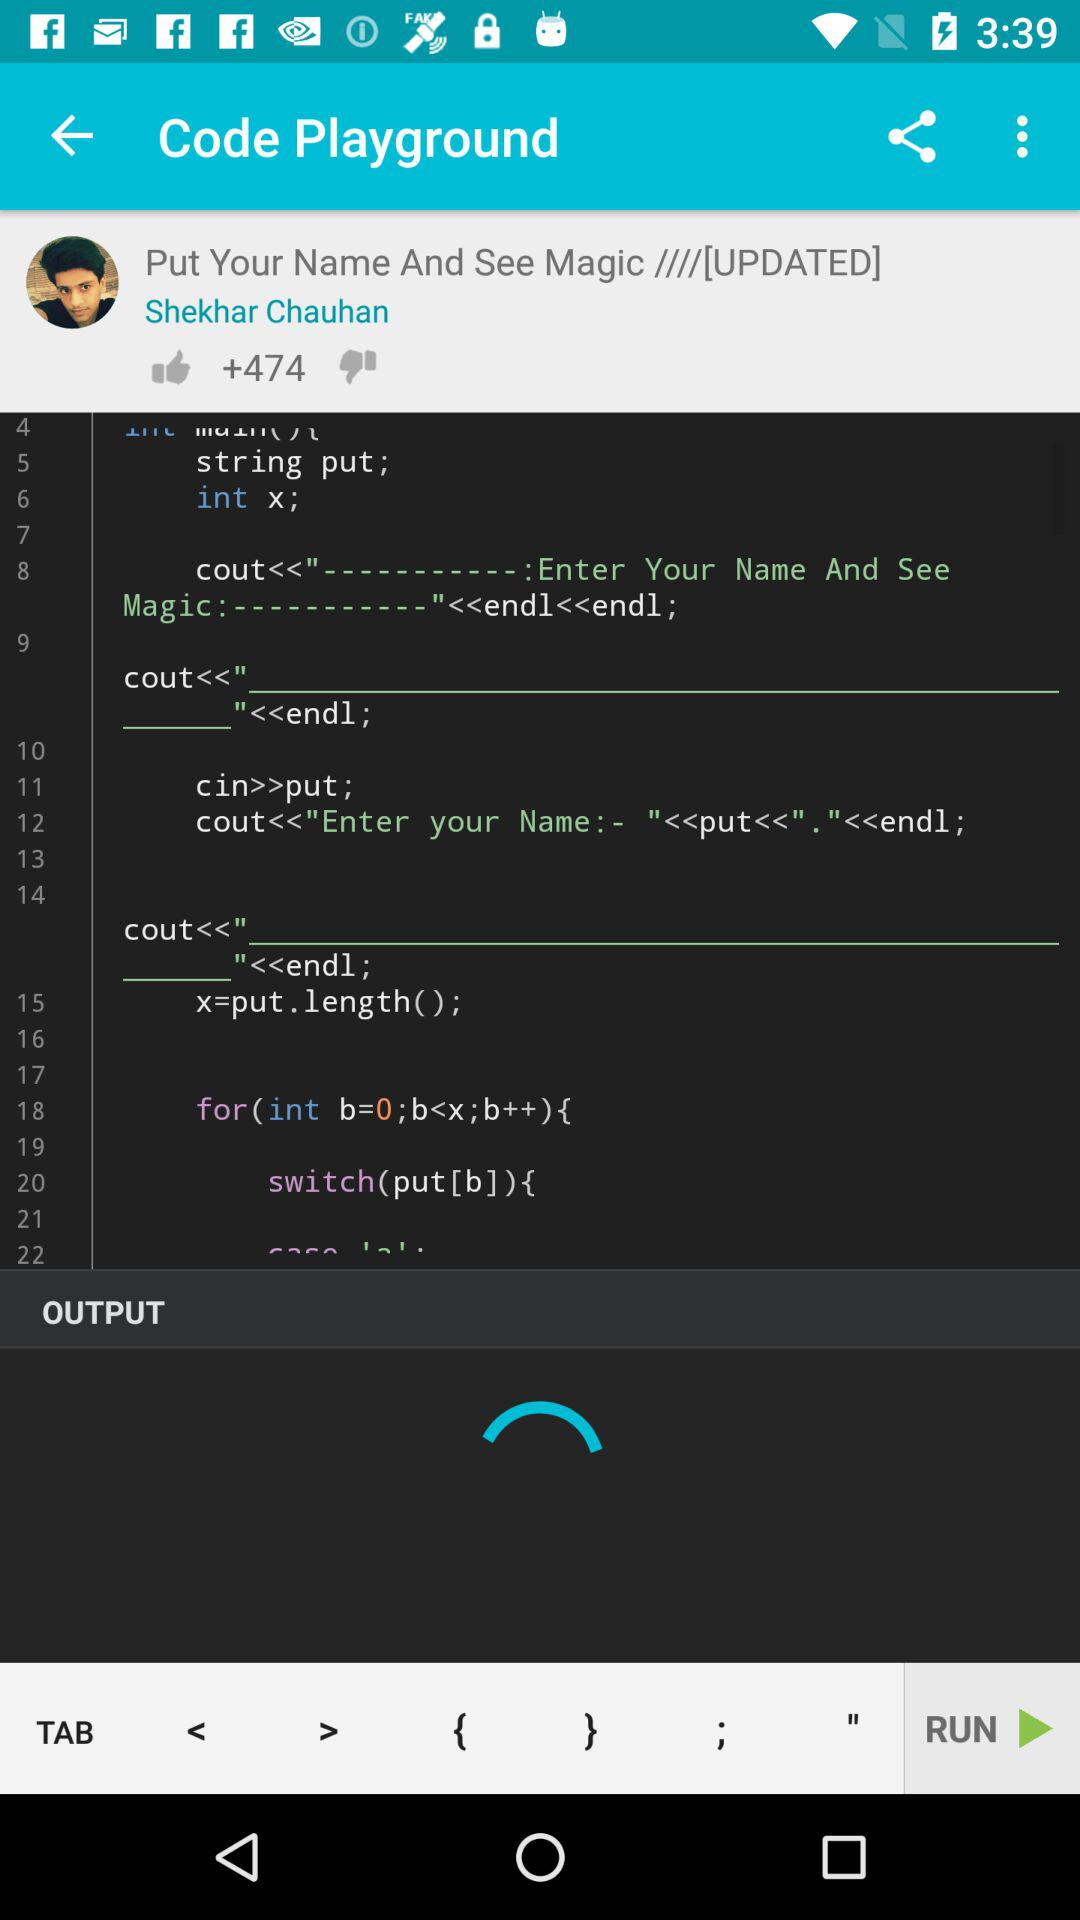What is the name of the user? The name of the user is Shekhar Chauhan. 